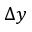<formula> <loc_0><loc_0><loc_500><loc_500>\Delta y</formula> 